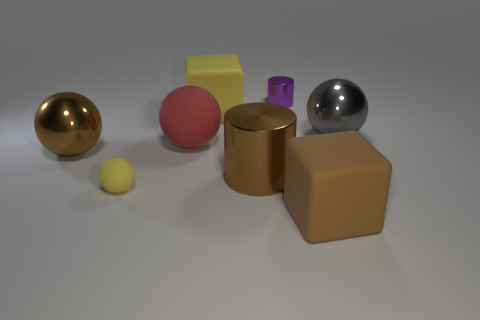Can you speculate about the placement of the objects? Do they appear to be arranged in a certain way for a specific purpose? The objects seem to be deliberately spaced out, possibly to showcase their individual shapes and colors as part of a display or a visual experiment. The arrangement doesn't suggest functional interaction, but rather an aesthetic or instructional purpose, perhaps to study the geometric forms and the interaction of light with different surfaces. 